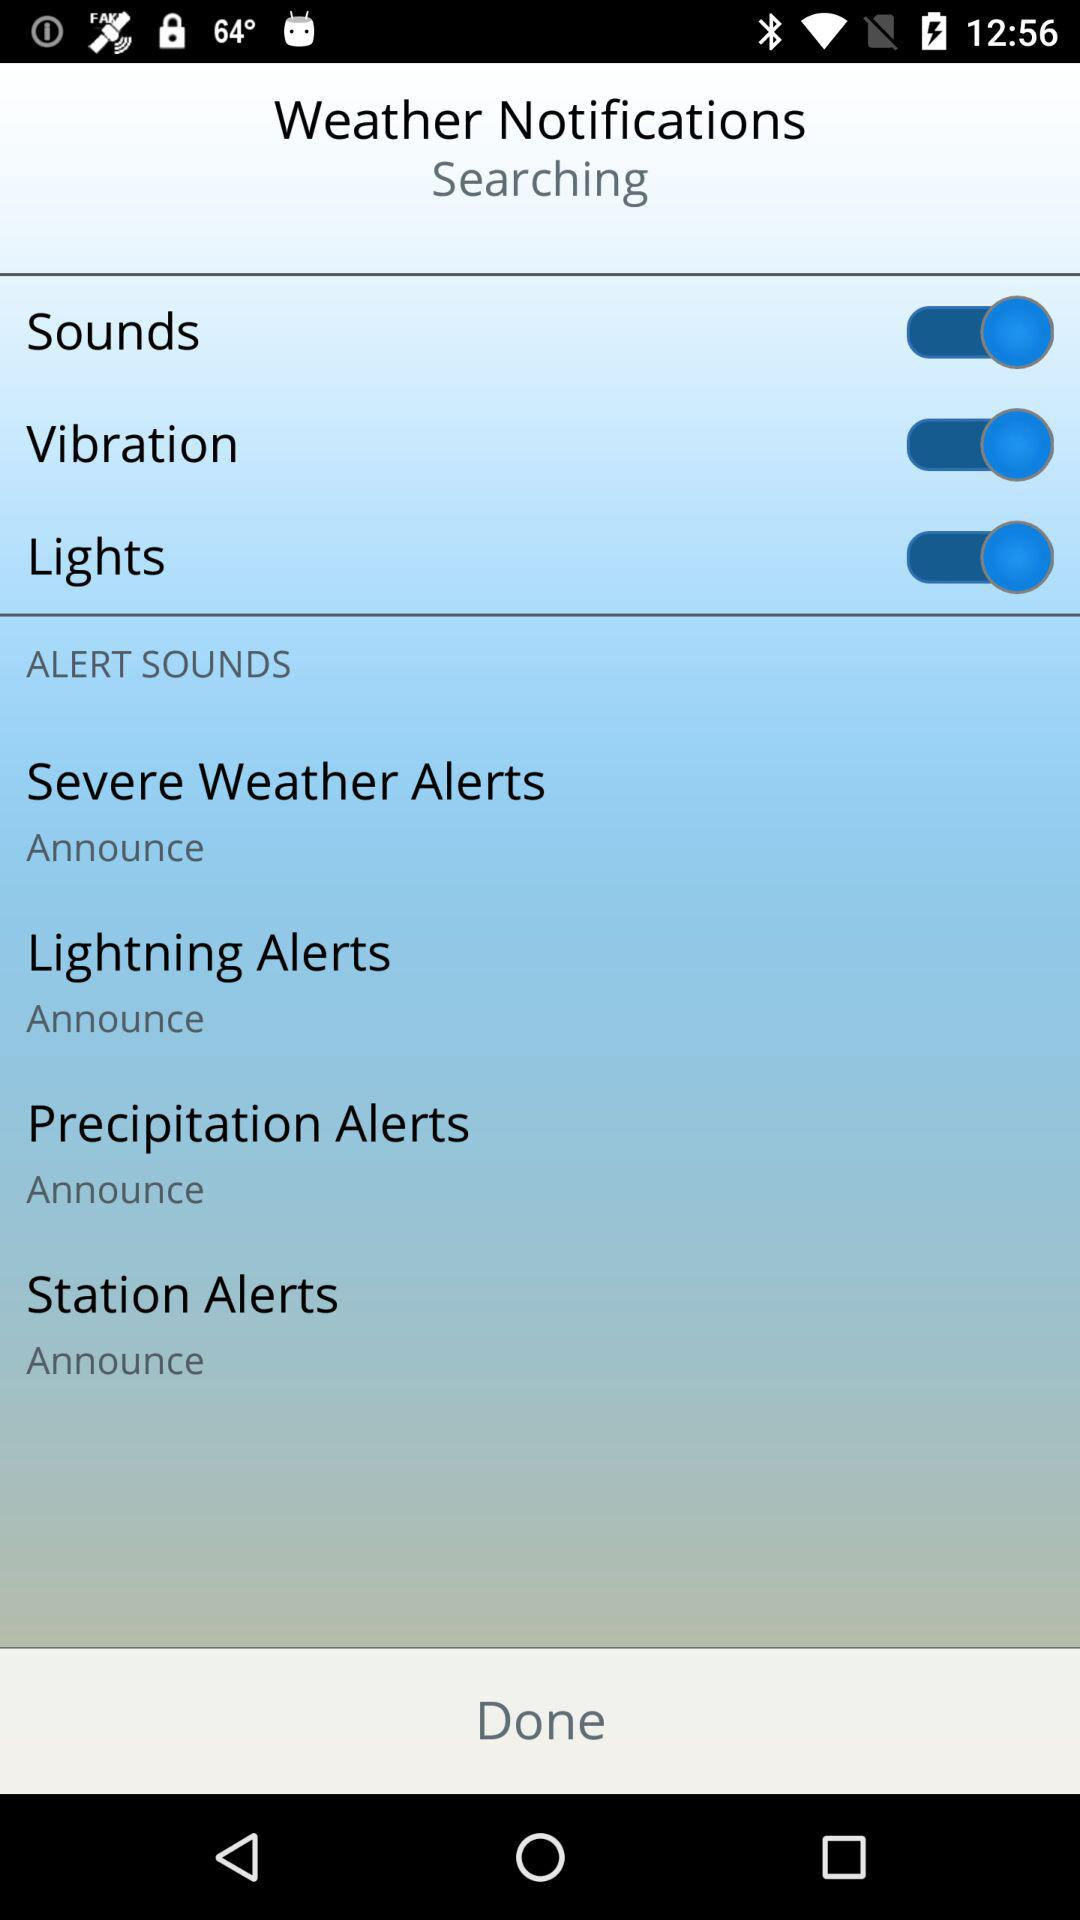How many alerts are there that have an announce option?
Answer the question using a single word or phrase. 4 